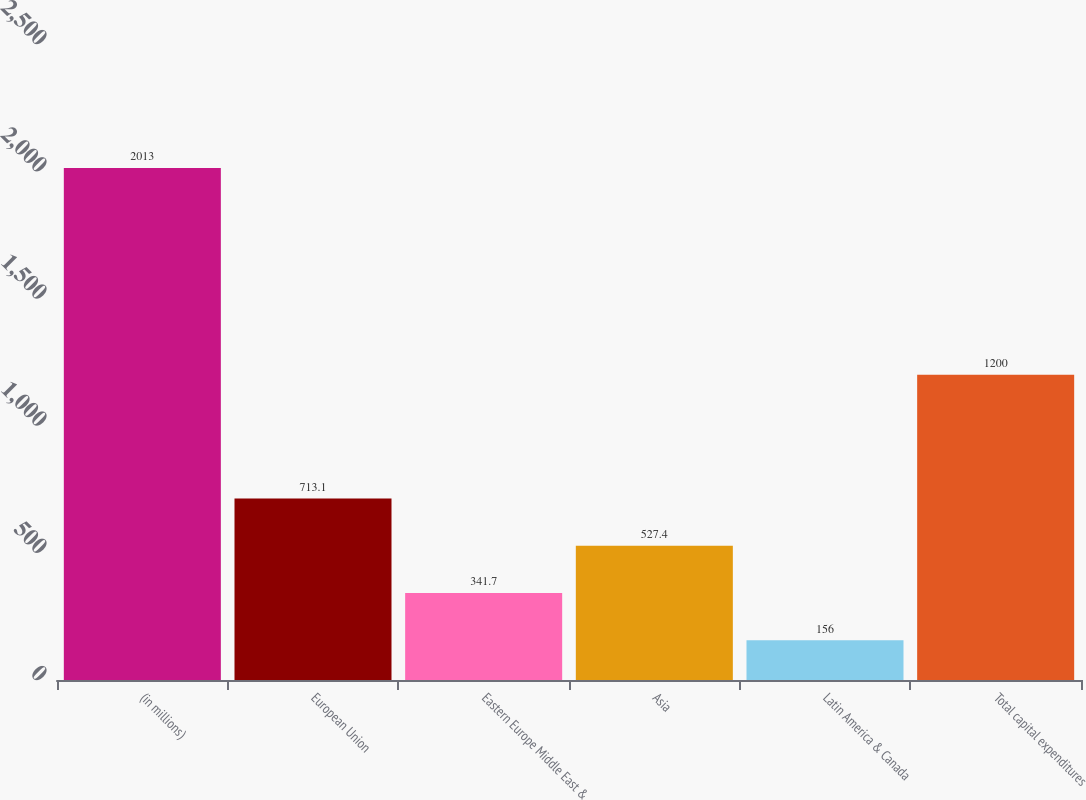<chart> <loc_0><loc_0><loc_500><loc_500><bar_chart><fcel>(in millions)<fcel>European Union<fcel>Eastern Europe Middle East &<fcel>Asia<fcel>Latin America & Canada<fcel>Total capital expenditures<nl><fcel>2013<fcel>713.1<fcel>341.7<fcel>527.4<fcel>156<fcel>1200<nl></chart> 